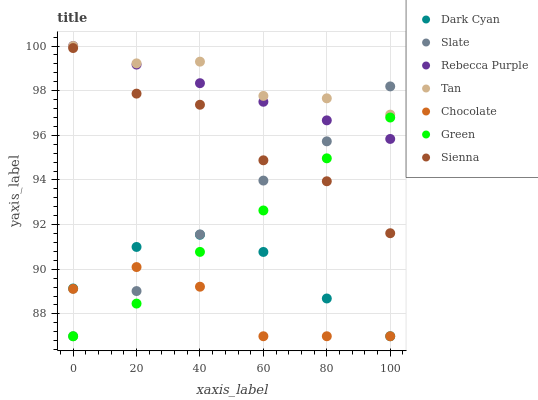Does Chocolate have the minimum area under the curve?
Answer yes or no. Yes. Does Tan have the maximum area under the curve?
Answer yes or no. Yes. Does Sienna have the minimum area under the curve?
Answer yes or no. No. Does Sienna have the maximum area under the curve?
Answer yes or no. No. Is Rebecca Purple the smoothest?
Answer yes or no. Yes. Is Sienna the roughest?
Answer yes or no. Yes. Is Chocolate the smoothest?
Answer yes or no. No. Is Chocolate the roughest?
Answer yes or no. No. Does Slate have the lowest value?
Answer yes or no. Yes. Does Sienna have the lowest value?
Answer yes or no. No. Does Tan have the highest value?
Answer yes or no. Yes. Does Sienna have the highest value?
Answer yes or no. No. Is Dark Cyan less than Rebecca Purple?
Answer yes or no. Yes. Is Rebecca Purple greater than Dark Cyan?
Answer yes or no. Yes. Does Tan intersect Slate?
Answer yes or no. Yes. Is Tan less than Slate?
Answer yes or no. No. Is Tan greater than Slate?
Answer yes or no. No. Does Dark Cyan intersect Rebecca Purple?
Answer yes or no. No. 